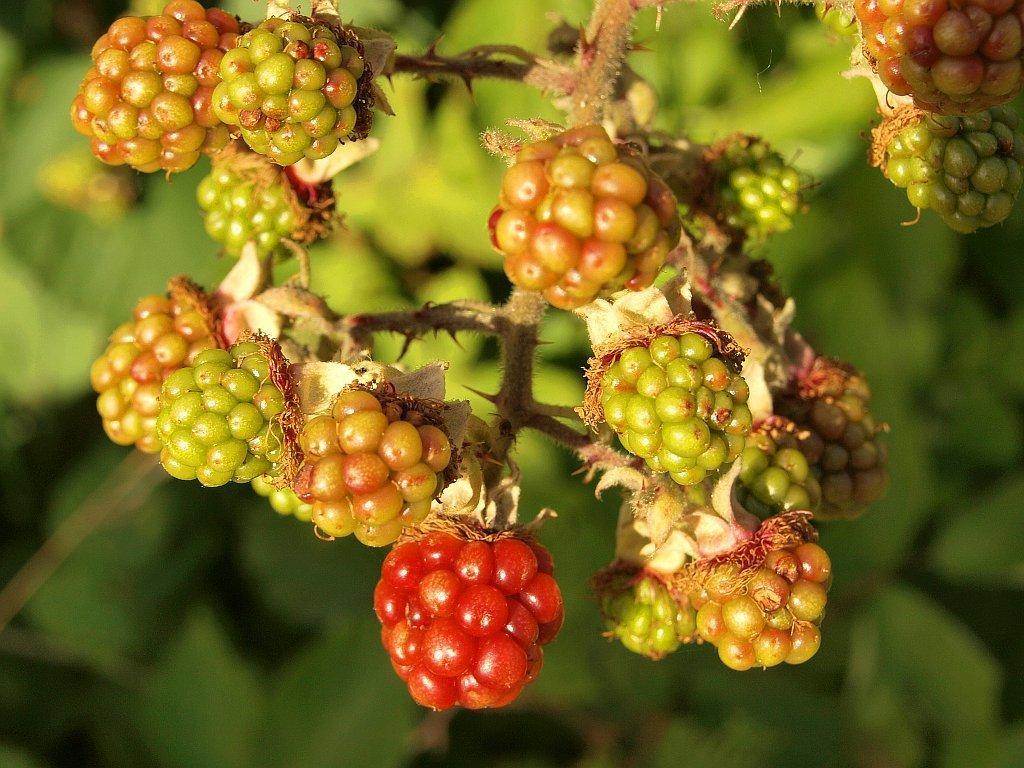Describe this image in one or two sentences. In this image there are fruits cherries in the foreground. And in the background it looks like there are leaves and the image is blur. 